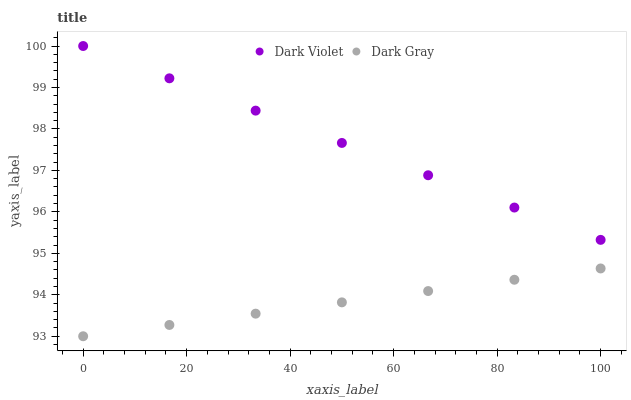Does Dark Gray have the minimum area under the curve?
Answer yes or no. Yes. Does Dark Violet have the maximum area under the curve?
Answer yes or no. Yes. Does Dark Violet have the minimum area under the curve?
Answer yes or no. No. Is Dark Violet the smoothest?
Answer yes or no. Yes. Is Dark Gray the roughest?
Answer yes or no. Yes. Is Dark Violet the roughest?
Answer yes or no. No. Does Dark Gray have the lowest value?
Answer yes or no. Yes. Does Dark Violet have the lowest value?
Answer yes or no. No. Does Dark Violet have the highest value?
Answer yes or no. Yes. Is Dark Gray less than Dark Violet?
Answer yes or no. Yes. Is Dark Violet greater than Dark Gray?
Answer yes or no. Yes. Does Dark Gray intersect Dark Violet?
Answer yes or no. No. 